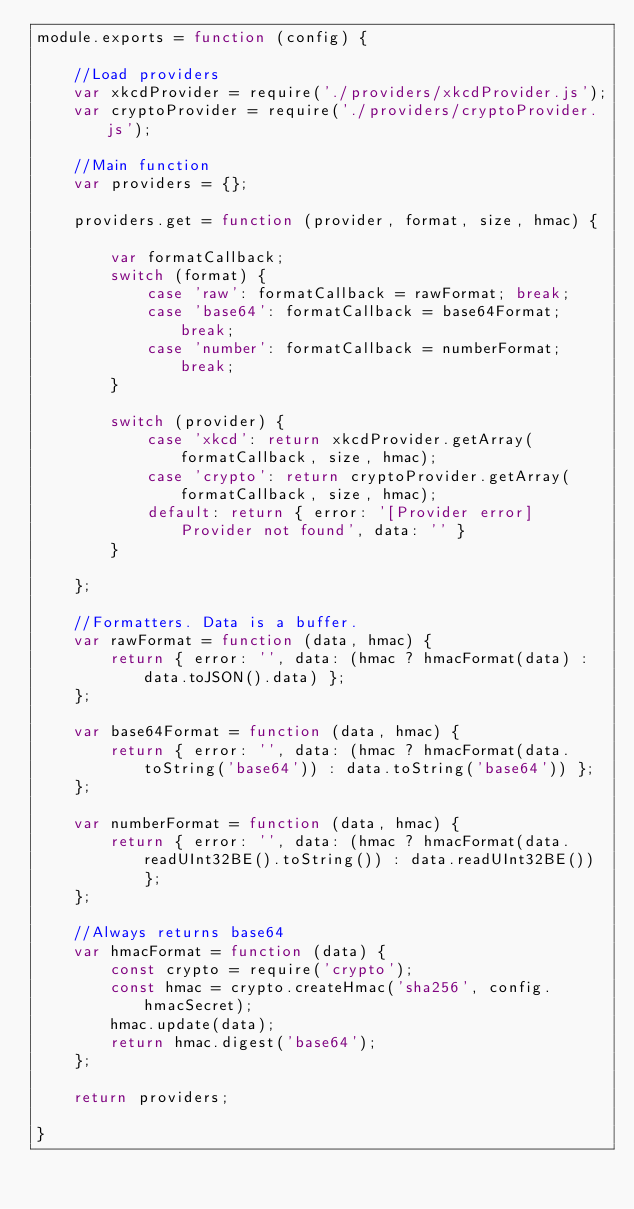Convert code to text. <code><loc_0><loc_0><loc_500><loc_500><_JavaScript_>module.exports = function (config) {

    //Load providers
    var xkcdProvider = require('./providers/xkcdProvider.js');
    var cryptoProvider = require('./providers/cryptoProvider.js');

    //Main function
    var providers = {};

    providers.get = function (provider, format, size, hmac) {

        var formatCallback;
        switch (format) {
            case 'raw': formatCallback = rawFormat; break;
            case 'base64': formatCallback = base64Format; break;
            case 'number': formatCallback = numberFormat; break;
        }

        switch (provider) {
            case 'xkcd': return xkcdProvider.getArray(formatCallback, size, hmac);
            case 'crypto': return cryptoProvider.getArray(formatCallback, size, hmac);
            default: return { error: '[Provider error] Provider not found', data: '' }
        }

    };

    //Formatters. Data is a buffer.
    var rawFormat = function (data, hmac) {
        return { error: '', data: (hmac ? hmacFormat(data) : data.toJSON().data) };
    };

    var base64Format = function (data, hmac) {
        return { error: '', data: (hmac ? hmacFormat(data.toString('base64')) : data.toString('base64')) };
    };

    var numberFormat = function (data, hmac) {
        return { error: '', data: (hmac ? hmacFormat(data.readUInt32BE().toString()) : data.readUInt32BE()) };
    };

    //Always returns base64
    var hmacFormat = function (data) {
        const crypto = require('crypto');
        const hmac = crypto.createHmac('sha256', config.hmacSecret);
        hmac.update(data);
        return hmac.digest('base64');
    };

    return providers;

}
</code> 